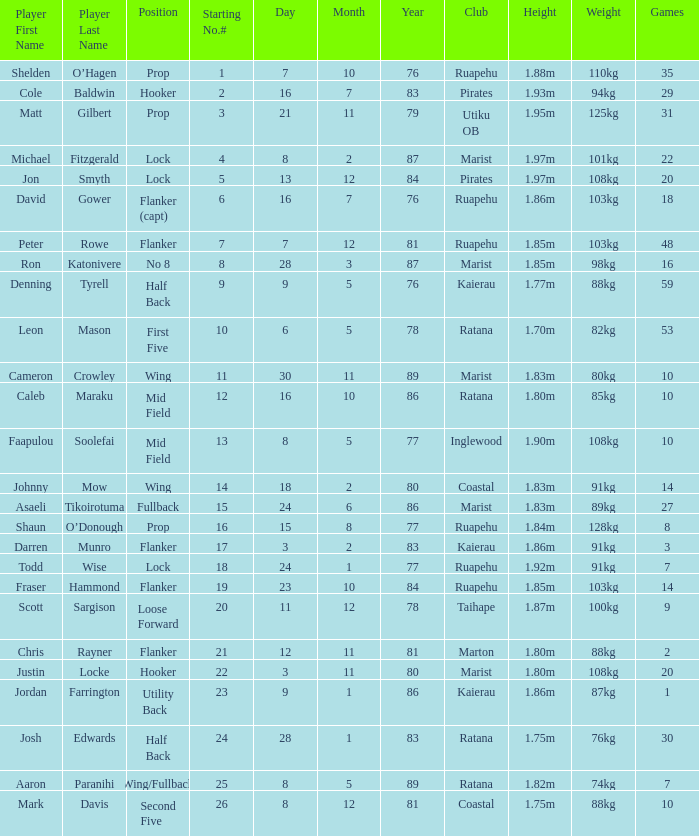Could you parse the entire table? {'header': ['Player First Name', 'Player Last Name', 'Position', 'Starting No.#', 'Day', 'Month', 'Year', 'Club', 'Height', 'Weight', 'Games'], 'rows': [['Shelden', 'O’Hagen', 'Prop', '1', '7', '10', '76', 'Ruapehu', '1.88m', '110kg', '35'], ['Cole', 'Baldwin', 'Hooker', '2', '16', '7', '83', 'Pirates', '1.93m', '94kg', '29'], ['Matt', 'Gilbert', 'Prop', '3', '21', '11', '79', 'Utiku OB', '1.95m', '125kg', '31'], ['Michael', 'Fitzgerald', 'Lock', '4', '8', '2', '87', 'Marist', '1.97m', '101kg', '22'], ['Jon', 'Smyth', 'Lock', '5', '13', '12', '84', 'Pirates', '1.97m', '108kg', '20'], ['David', 'Gower', 'Flanker (capt)', '6', '16', '7', '76', 'Ruapehu', '1.86m', '103kg', '18'], ['Peter', 'Rowe', 'Flanker', '7', '7', '12', '81', 'Ruapehu', '1.85m', '103kg', '48'], ['Ron', 'Katonivere', 'No 8', '8', '28', '3', '87', 'Marist', '1.85m', '98kg', '16'], ['Denning', 'Tyrell', 'Half Back', '9', '9', '5', '76', 'Kaierau', '1.77m', '88kg', '59'], ['Leon', 'Mason', 'First Five', '10', '6', '5', '78', 'Ratana', '1.70m', '82kg', '53'], ['Cameron', 'Crowley', 'Wing', '11', '30', '11', '89', 'Marist', '1.83m', '80kg', '10'], ['Caleb', 'Maraku', 'Mid Field', '12', '16', '10', '86', 'Ratana', '1.80m', '85kg', '10'], ['Faapulou', 'Soolefai', 'Mid Field', '13', '8', '5', '77', 'Inglewood', '1.90m', '108kg', '10'], ['Johnny', 'Mow', 'Wing', '14', '18', '2', '80', 'Coastal', '1.83m', '91kg', '14'], ['Asaeli', 'Tikoirotuma', 'Fullback', '15', '24', '6', '86', 'Marist', '1.83m', '89kg', '27'], ['Shaun', 'O’Donough', 'Prop', '16', '15', '8', '77', 'Ruapehu', '1.84m', '128kg', '8'], ['Darren', 'Munro', 'Flanker', '17', '3', '2', '83', 'Kaierau', '1.86m', '91kg', '3'], ['Todd', 'Wise', 'Lock', '18', '24', '1', '77', 'Ruapehu', '1.92m', '91kg', '7'], ['Fraser', 'Hammond', 'Flanker', '19', '23', '10', '84', 'Ruapehu', '1.85m', '103kg', '14'], ['Scott', 'Sargison', 'Loose Forward', '20', '11', '12', '78', 'Taihape', '1.87m', '100kg', '9'], ['Chris', 'Rayner', 'Flanker', '21', '12', '11', '81', 'Marton', '1.80m', '88kg', '2'], ['Justin', 'Locke', 'Hooker', '22', '3', '11', '80', 'Marist', '1.80m', '108kg', '20'], ['Jordan', 'Farrington', 'Utility Back', '23', '9', '1', '86', 'Kaierau', '1.86m', '87kg', '1'], ['Josh', 'Edwards', 'Half Back', '24', '28', '1', '83', 'Ratana', '1.75m', '76kg', '30'], ['Aaron', 'Paranihi', 'Wing/Fullback', '25', '8', '5', '89', 'Ratana', '1.82m', '74kg', '7'], ['Mark', 'Davis', 'Second Five', '26', '8', '12', '81', 'Coastal', '1.75m', '88kg', '10']]} Can you identify the player who has a 76kg weight? Josh Edwards. 